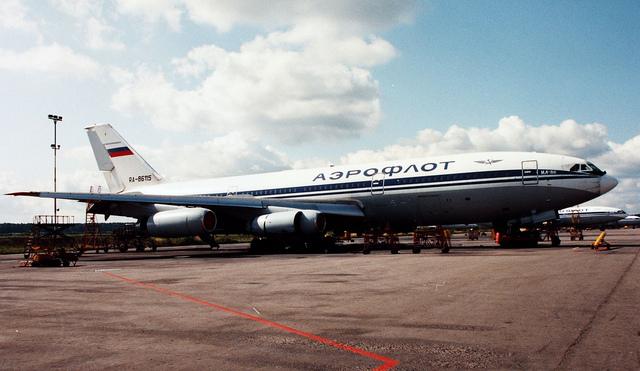Does this plane have design elements reminiscent of a party?
Keep it brief. No. What color is the stripe on the ground?
Quick response, please. Red. Is the weather cloudy?
Answer briefly. Yes. What language is on the plane?
Concise answer only. Russian. How many engines on the plane?
Concise answer only. 4. 